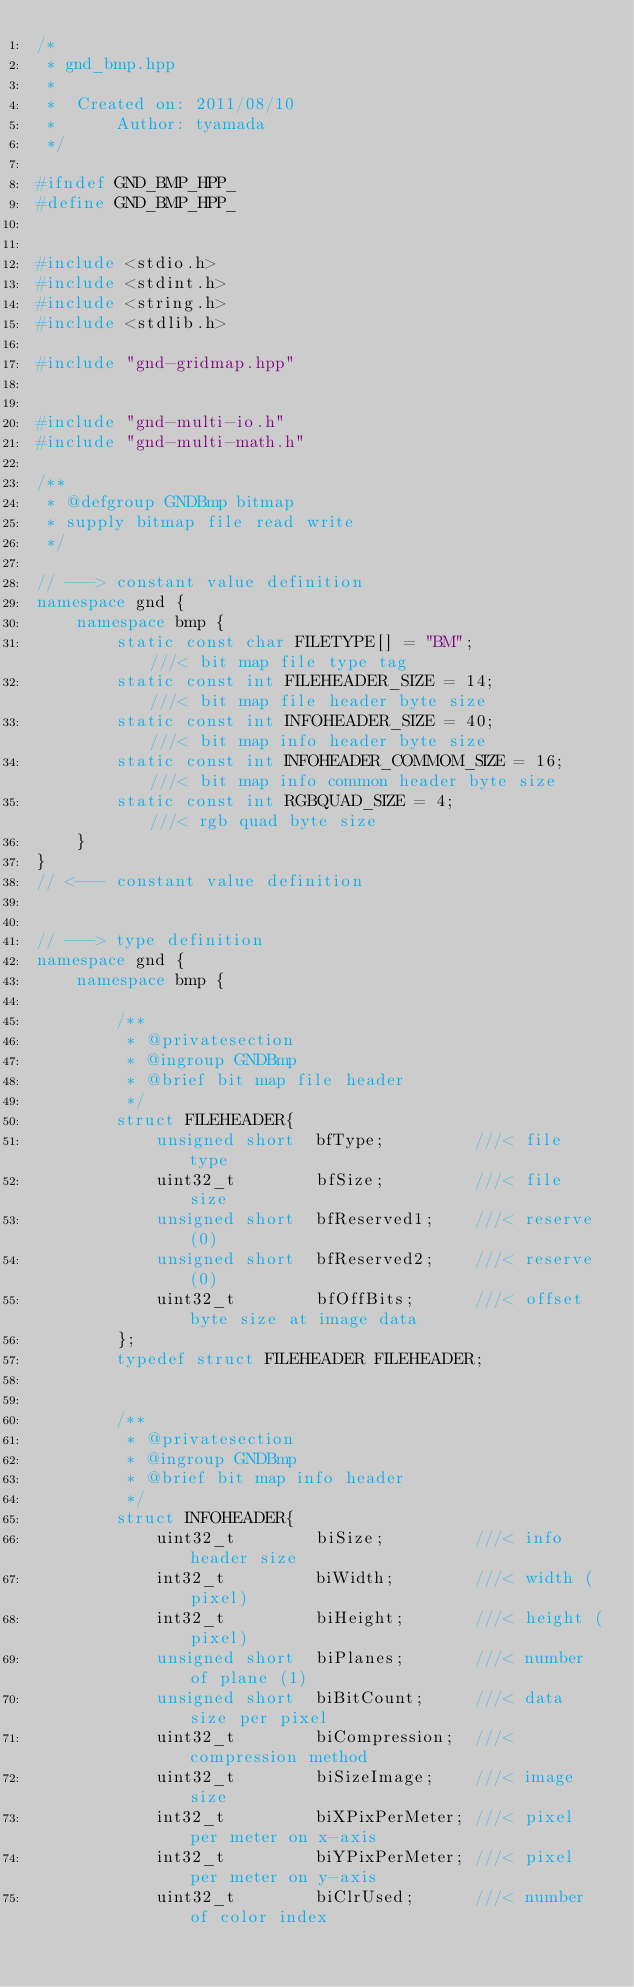Convert code to text. <code><loc_0><loc_0><loc_500><loc_500><_C++_>/*
 * gnd_bmp.hpp
 *
 *  Created on: 2011/08/10
 *      Author: tyamada
 */

#ifndef GND_BMP_HPP_
#define GND_BMP_HPP_


#include <stdio.h>
#include <stdint.h>
#include <string.h>
#include <stdlib.h>

#include "gnd-gridmap.hpp"


#include "gnd-multi-io.h"
#include "gnd-multi-math.h"

/**
 * @defgroup GNDBmp bitmap
 * supply bitmap file read write
 */

// ---> constant value definition
namespace gnd {
	namespace bmp {
		static const char FILETYPE[] = "BM";			///< bit map file type tag
		static const int FILEHEADER_SIZE = 14;			///< bit map file header byte size
		static const int INFOHEADER_SIZE = 40;			///< bit map info header byte size
		static const int INFOHEADER_COMMOM_SIZE = 16;	///< bit map info common header byte size
		static const int RGBQUAD_SIZE = 4;				///< rgb quad byte size
	}
}
// <--- constant value definition


// ---> type definition
namespace gnd {
	namespace bmp {

		/**
		 * @privatesection
		 * @ingroup GNDBmp
		 * @brief bit map file header
		 */
		struct FILEHEADER{
			unsigned short	bfType;			///< file type
			uint32_t		bfSize;			///< file size
			unsigned short	bfReserved1;	///< reserve (0)
			unsigned short	bfReserved2;	///< reserve (0)
			uint32_t		bfOffBits;		///< offset byte size at image data
		};
		typedef struct FILEHEADER FILEHEADER;


		/**
		 * @privatesection
		 * @ingroup GNDBmp
		 * @brief bit map info header
		 */
		struct INFOHEADER{
			uint32_t		biSize;			///< info header size
			int32_t			biWidth;		///< width (pixel)
			int32_t			biHeight;		///< height (pixel)
			unsigned short	biPlanes;		///< number of plane (1)
			unsigned short	biBitCount;		///< data size per pixel
			uint32_t  		biCompression;	///< compression method
			uint32_t		biSizeImage;	///< image size
			int32_t			biXPixPerMeter;	///< pixel per meter on x-axis
			int32_t			biYPixPerMeter;	///< pixel per meter on y-axis
			uint32_t		biClrUsed;		///< number of color index</code> 